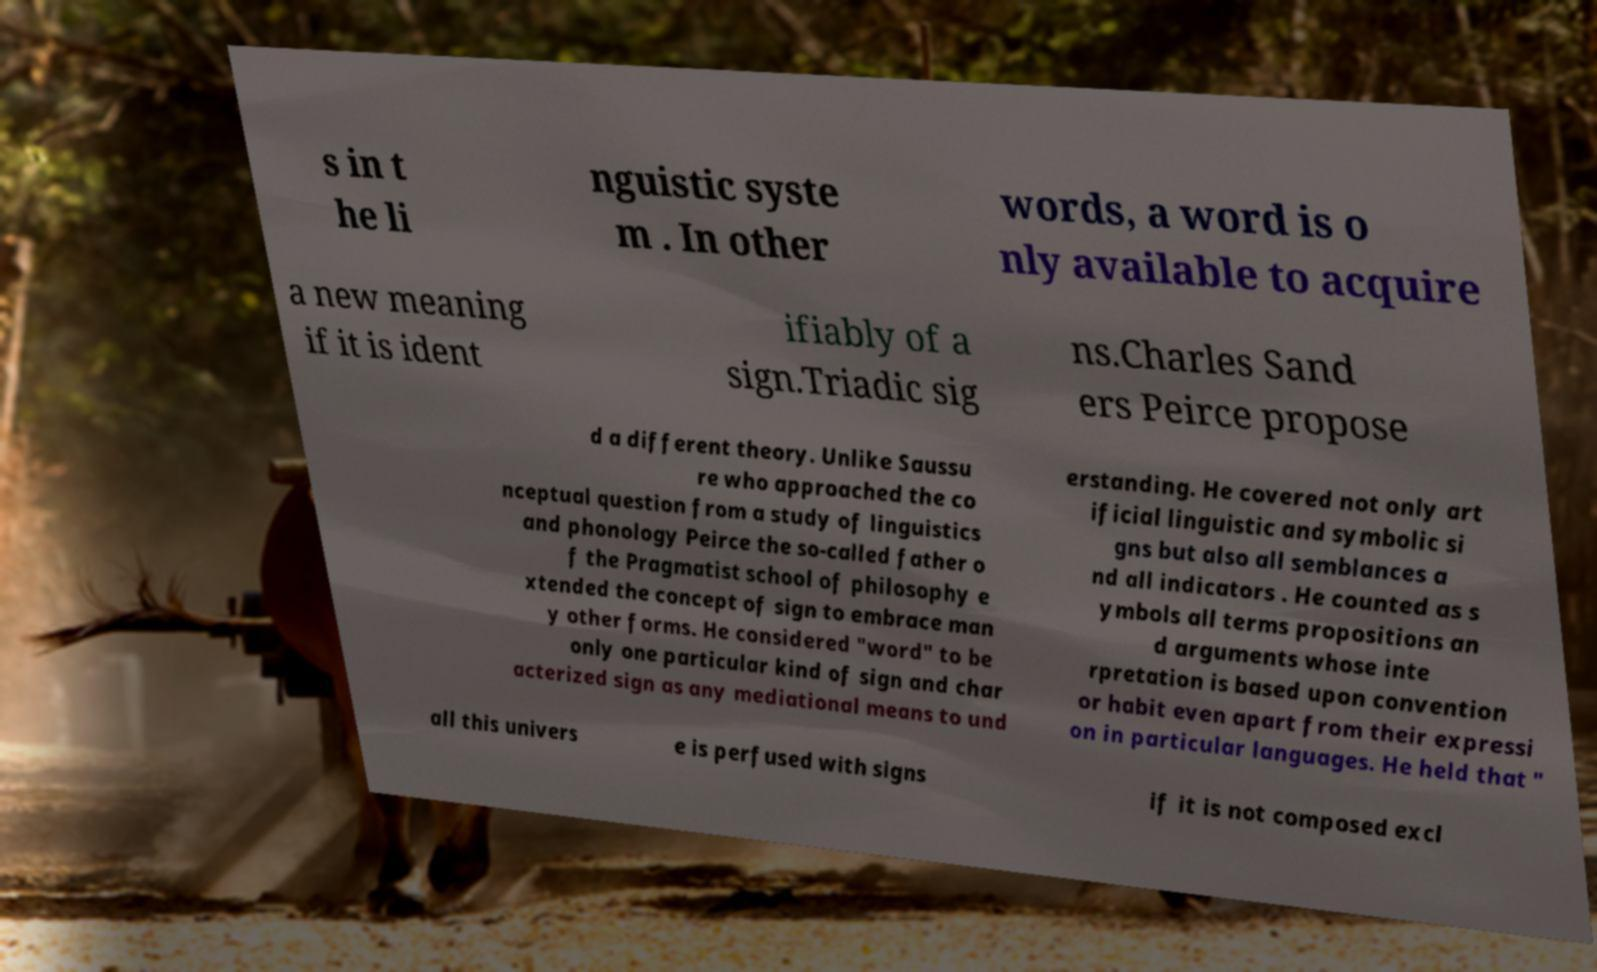I need the written content from this picture converted into text. Can you do that? s in t he li nguistic syste m . In other words, a word is o nly available to acquire a new meaning if it is ident ifiably of a sign.Triadic sig ns.Charles Sand ers Peirce propose d a different theory. Unlike Saussu re who approached the co nceptual question from a study of linguistics and phonology Peirce the so-called father o f the Pragmatist school of philosophy e xtended the concept of sign to embrace man y other forms. He considered "word" to be only one particular kind of sign and char acterized sign as any mediational means to und erstanding. He covered not only art ificial linguistic and symbolic si gns but also all semblances a nd all indicators . He counted as s ymbols all terms propositions an d arguments whose inte rpretation is based upon convention or habit even apart from their expressi on in particular languages. He held that " all this univers e is perfused with signs if it is not composed excl 